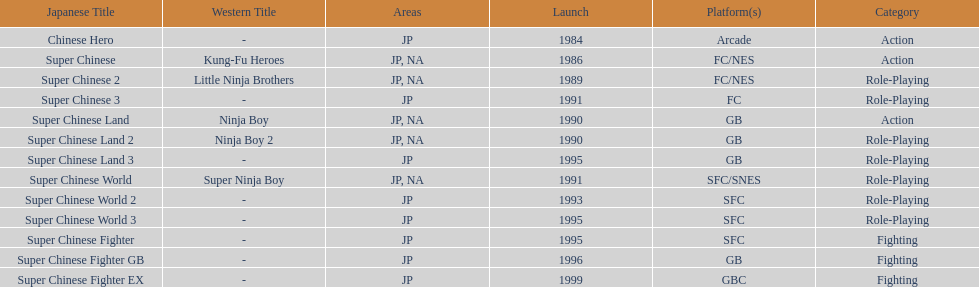When was the last super chinese game released? 1999. 